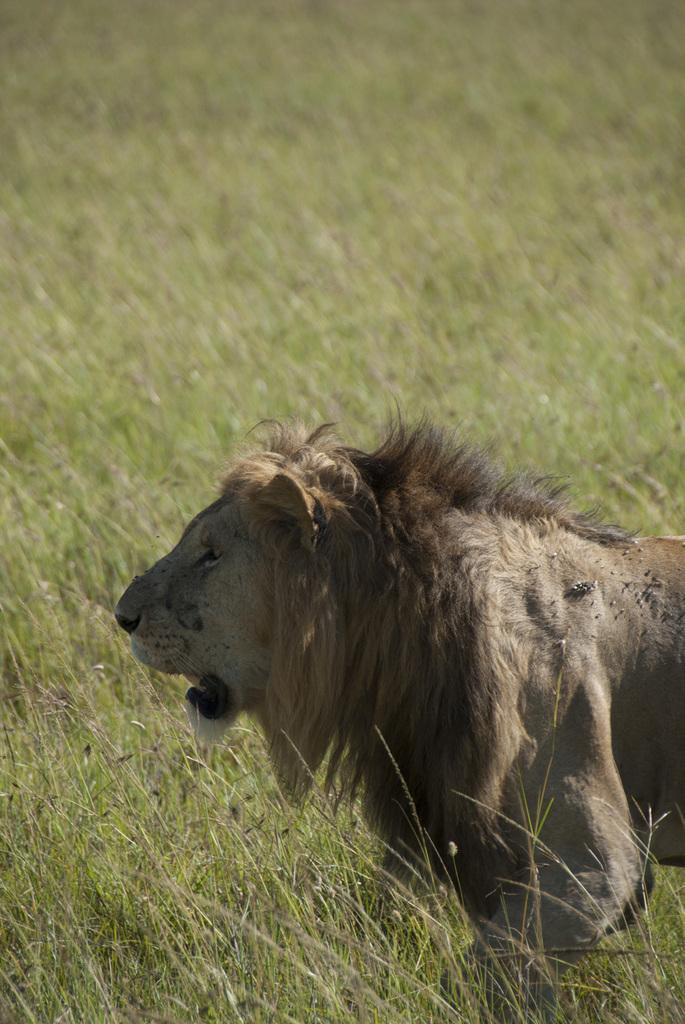Please provide a concise description of this image. In this image there is a lion at right side of this image and there is a grass in the background. 